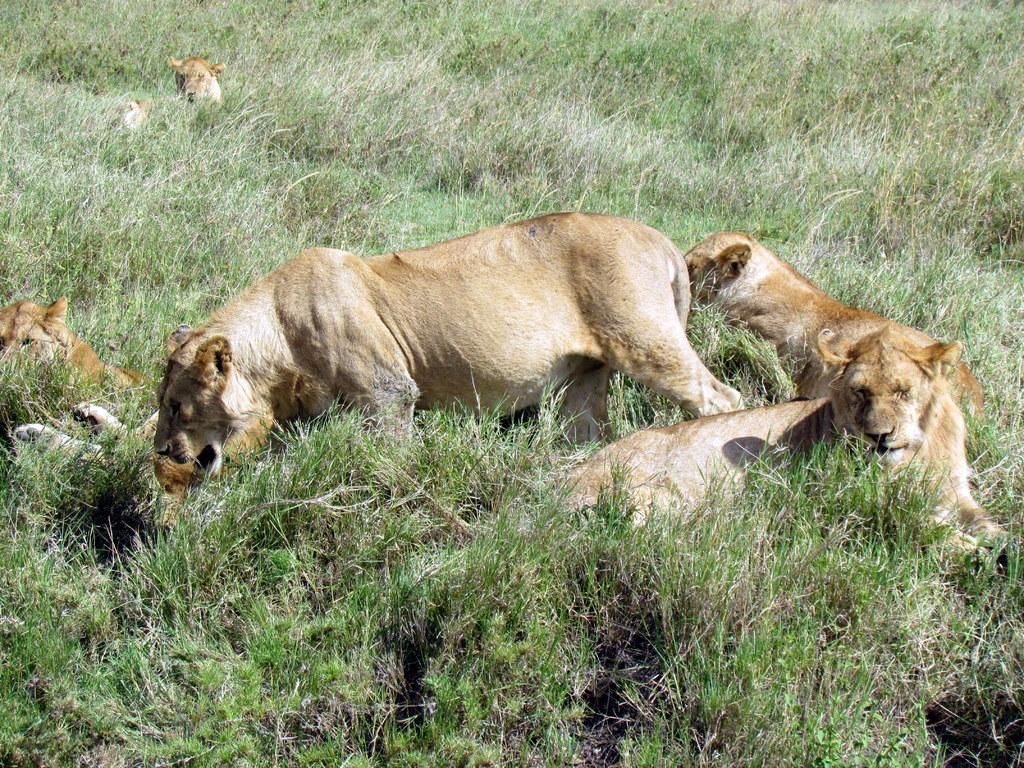What animals are present in the image? There is a group of lions in the image. Where are the lions located? The lions are on the ground. What type of vegetation can be seen in the image? There is grass visible in the image. How many dinosaurs can be seen interacting with the lions in the image? There are no dinosaurs present in the image; it features a group of lions on the ground with grass visible. 